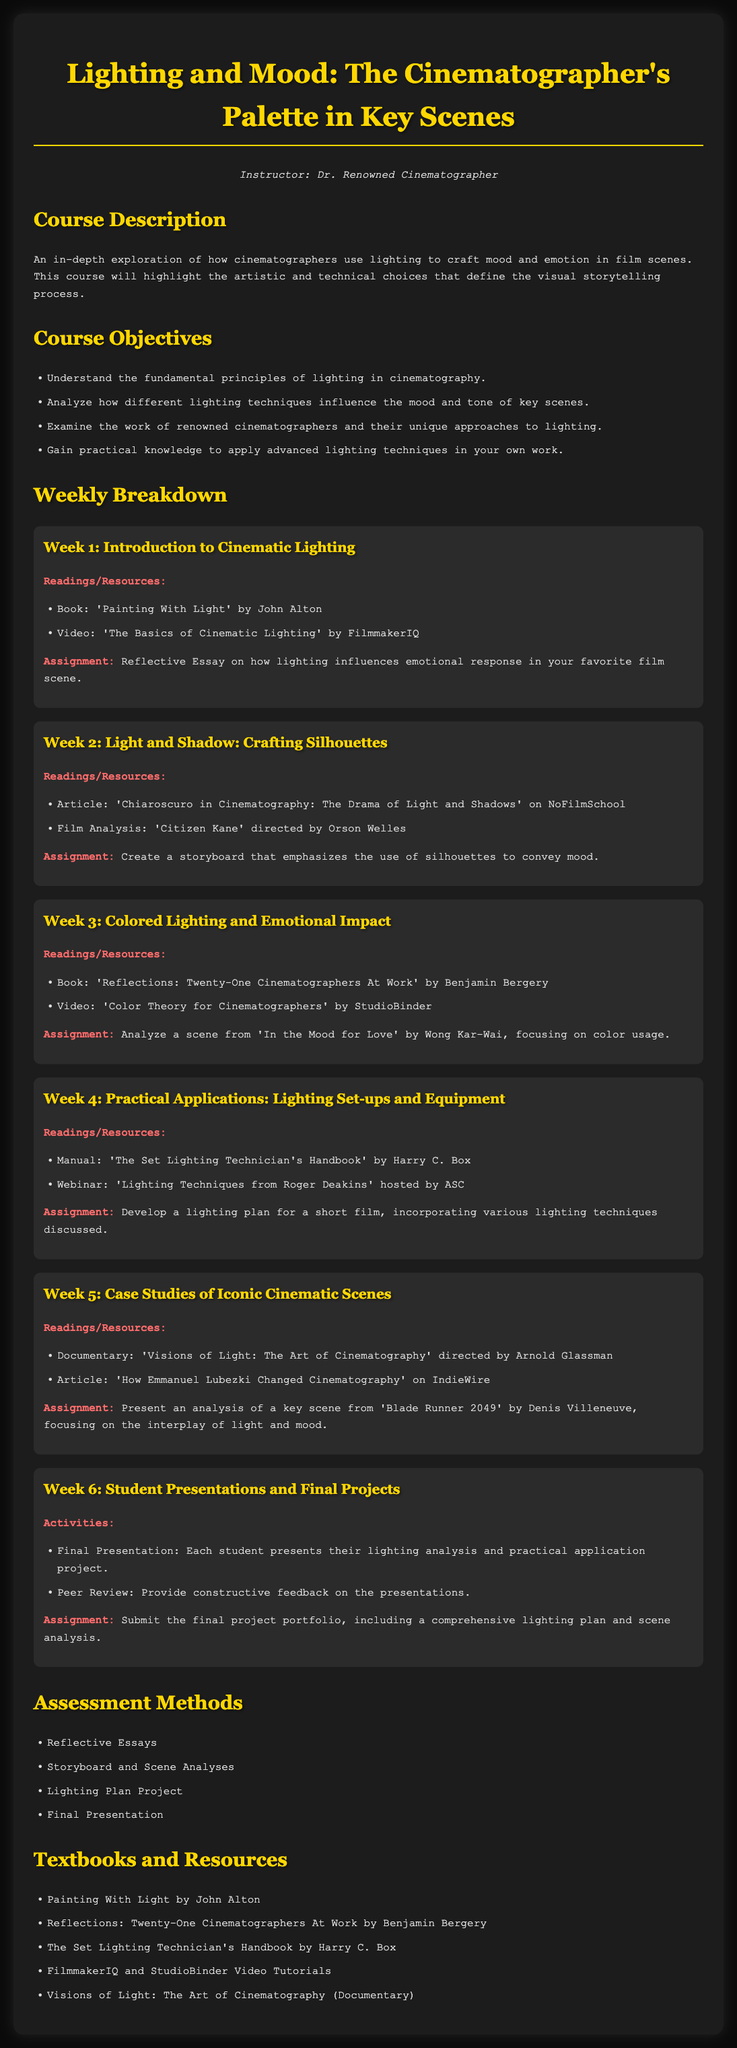What is the title of the course? The title of the course is provided in the heading at the beginning of the document.
Answer: Lighting and Mood: The Cinematographer's Palette in Key Scenes Who is the instructor for the course? The instructor's name is mentioned in the introduction section of the document.
Answer: Dr. Renowned Cinematographer What is the main focus of Week 1? Week 1 outlines the subject matter, which is detailed in the week breakdown section of the document.
Answer: Introduction to Cinematic Lighting How many weeks are in the syllabus? The number of weeks can be determined by counting the sections in the weekly breakdown.
Answer: Six Which book is assigned in Week 3? The specific readings are listed under each week, including their titles.
Answer: Reflections: Twenty-One Cinematographers At Work What type of assignment is due in Week 5? The nature of assignments is described in each weekly section, indicating their type.
Answer: Analysis of a key scene Which lighting technique is emphasized in Week 2? The primary theme of Week 2 is stated in the week breakdown section.
Answer: Crafting Silhouettes What is the final project deliverable? The document specifies what students need to submit for their final project in the last week.
Answer: Final project portfolio What is the purpose of the reflective essay in Week 1? The assignment's purpose and content can be inferred from its description in the week breakdown.
Answer: Emotional response in a film scene 